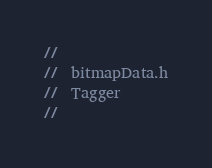Convert code to text. <code><loc_0><loc_0><loc_500><loc_500><_C_>//
//  bitmapData.h
//  Tagger
//</code> 